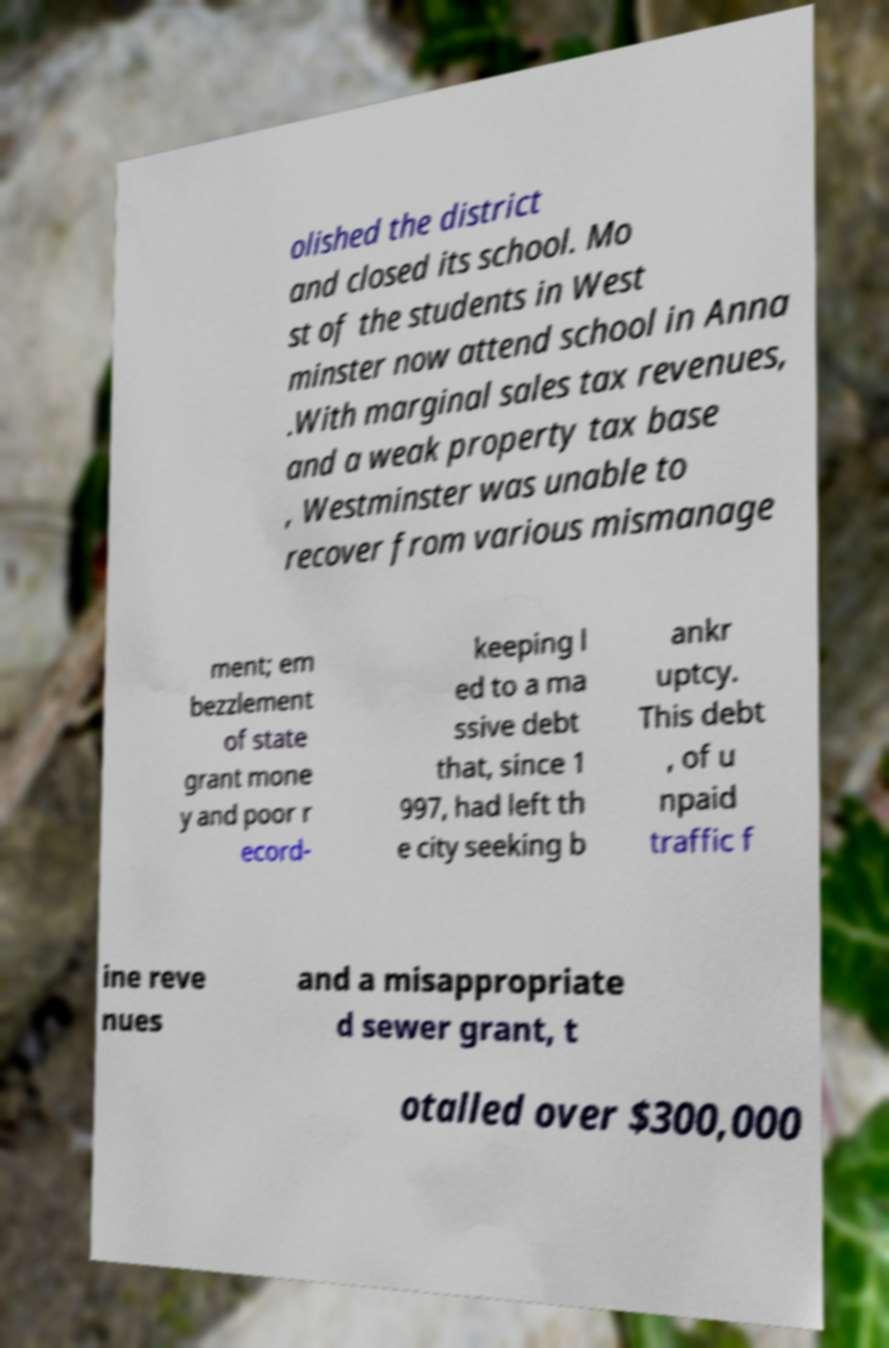Could you extract and type out the text from this image? olished the district and closed its school. Mo st of the students in West minster now attend school in Anna .With marginal sales tax revenues, and a weak property tax base , Westminster was unable to recover from various mismanage ment; em bezzlement of state grant mone y and poor r ecord- keeping l ed to a ma ssive debt that, since 1 997, had left th e city seeking b ankr uptcy. This debt , of u npaid traffic f ine reve nues and a misappropriate d sewer grant, t otalled over $300,000 